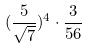<formula> <loc_0><loc_0><loc_500><loc_500>( \frac { 5 } { \sqrt { 7 } } ) ^ { 4 } \cdot \frac { 3 } { 5 6 }</formula> 